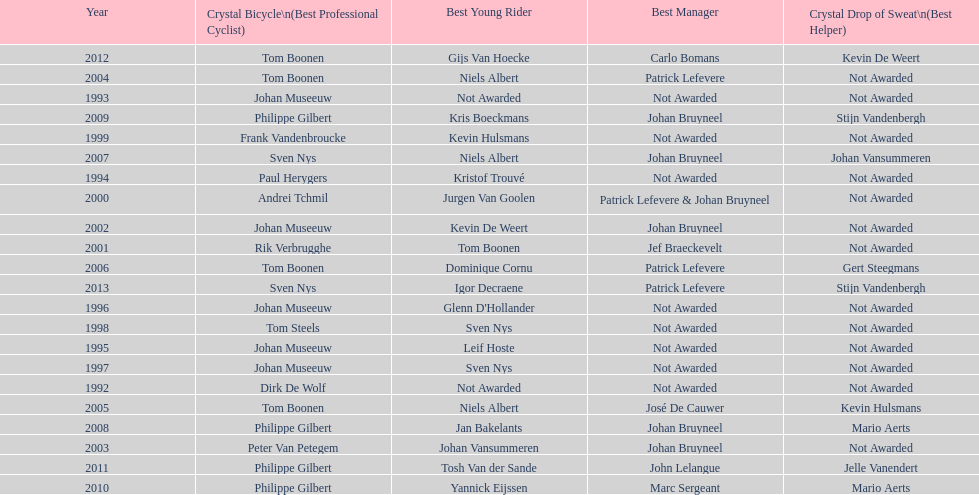Who has won the most best young rider awards? Niels Albert. 